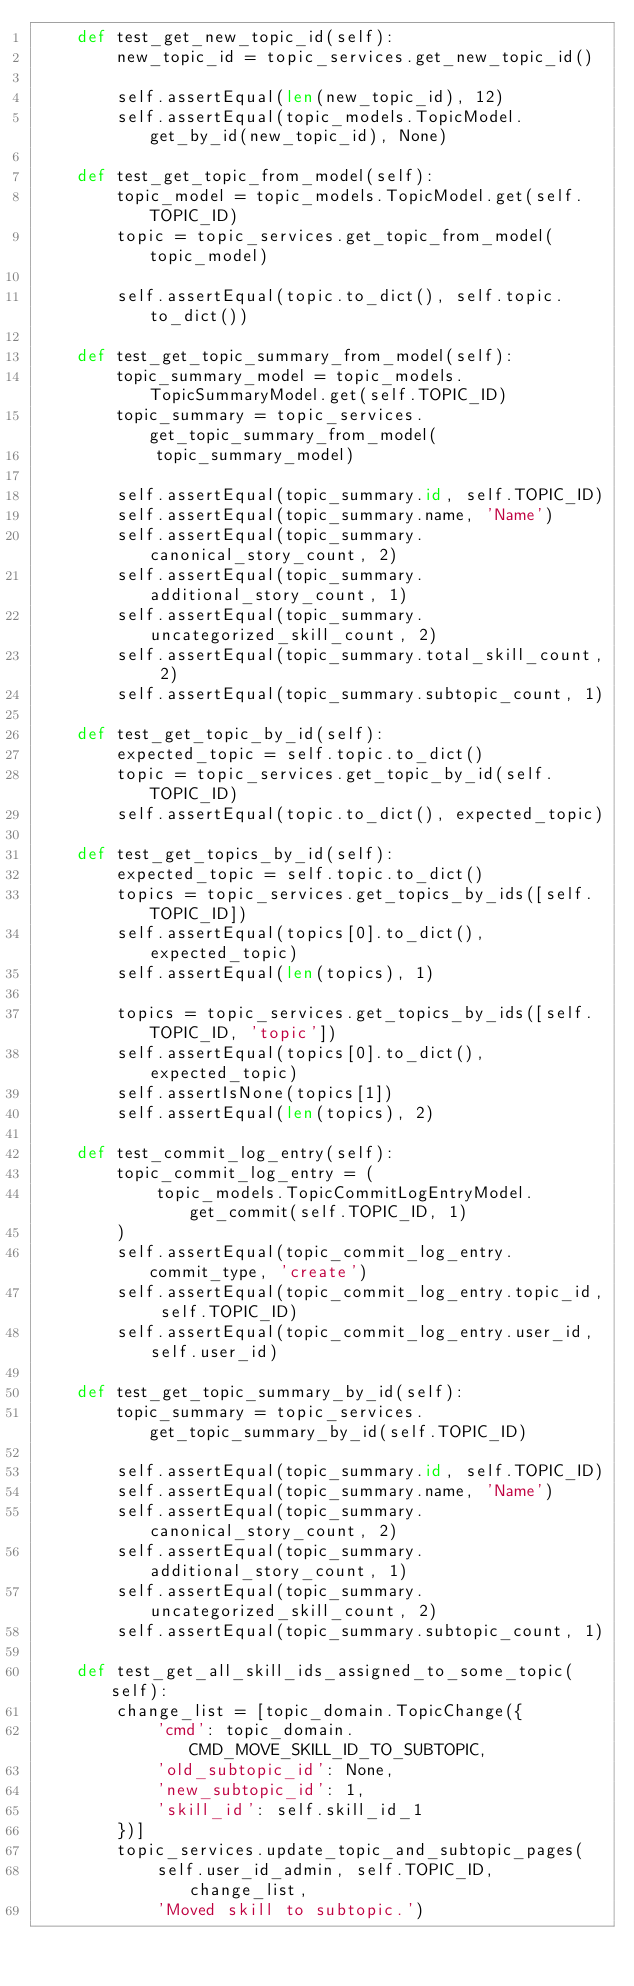Convert code to text. <code><loc_0><loc_0><loc_500><loc_500><_Python_>    def test_get_new_topic_id(self):
        new_topic_id = topic_services.get_new_topic_id()

        self.assertEqual(len(new_topic_id), 12)
        self.assertEqual(topic_models.TopicModel.get_by_id(new_topic_id), None)

    def test_get_topic_from_model(self):
        topic_model = topic_models.TopicModel.get(self.TOPIC_ID)
        topic = topic_services.get_topic_from_model(topic_model)

        self.assertEqual(topic.to_dict(), self.topic.to_dict())

    def test_get_topic_summary_from_model(self):
        topic_summary_model = topic_models.TopicSummaryModel.get(self.TOPIC_ID)
        topic_summary = topic_services.get_topic_summary_from_model(
            topic_summary_model)

        self.assertEqual(topic_summary.id, self.TOPIC_ID)
        self.assertEqual(topic_summary.name, 'Name')
        self.assertEqual(topic_summary.canonical_story_count, 2)
        self.assertEqual(topic_summary.additional_story_count, 1)
        self.assertEqual(topic_summary.uncategorized_skill_count, 2)
        self.assertEqual(topic_summary.total_skill_count, 2)
        self.assertEqual(topic_summary.subtopic_count, 1)

    def test_get_topic_by_id(self):
        expected_topic = self.topic.to_dict()
        topic = topic_services.get_topic_by_id(self.TOPIC_ID)
        self.assertEqual(topic.to_dict(), expected_topic)

    def test_get_topics_by_id(self):
        expected_topic = self.topic.to_dict()
        topics = topic_services.get_topics_by_ids([self.TOPIC_ID])
        self.assertEqual(topics[0].to_dict(), expected_topic)
        self.assertEqual(len(topics), 1)

        topics = topic_services.get_topics_by_ids([self.TOPIC_ID, 'topic'])
        self.assertEqual(topics[0].to_dict(), expected_topic)
        self.assertIsNone(topics[1])
        self.assertEqual(len(topics), 2)

    def test_commit_log_entry(self):
        topic_commit_log_entry = (
            topic_models.TopicCommitLogEntryModel.get_commit(self.TOPIC_ID, 1)
        )
        self.assertEqual(topic_commit_log_entry.commit_type, 'create')
        self.assertEqual(topic_commit_log_entry.topic_id, self.TOPIC_ID)
        self.assertEqual(topic_commit_log_entry.user_id, self.user_id)

    def test_get_topic_summary_by_id(self):
        topic_summary = topic_services.get_topic_summary_by_id(self.TOPIC_ID)

        self.assertEqual(topic_summary.id, self.TOPIC_ID)
        self.assertEqual(topic_summary.name, 'Name')
        self.assertEqual(topic_summary.canonical_story_count, 2)
        self.assertEqual(topic_summary.additional_story_count, 1)
        self.assertEqual(topic_summary.uncategorized_skill_count, 2)
        self.assertEqual(topic_summary.subtopic_count, 1)

    def test_get_all_skill_ids_assigned_to_some_topic(self):
        change_list = [topic_domain.TopicChange({
            'cmd': topic_domain.CMD_MOVE_SKILL_ID_TO_SUBTOPIC,
            'old_subtopic_id': None,
            'new_subtopic_id': 1,
            'skill_id': self.skill_id_1
        })]
        topic_services.update_topic_and_subtopic_pages(
            self.user_id_admin, self.TOPIC_ID, change_list,
            'Moved skill to subtopic.')</code> 